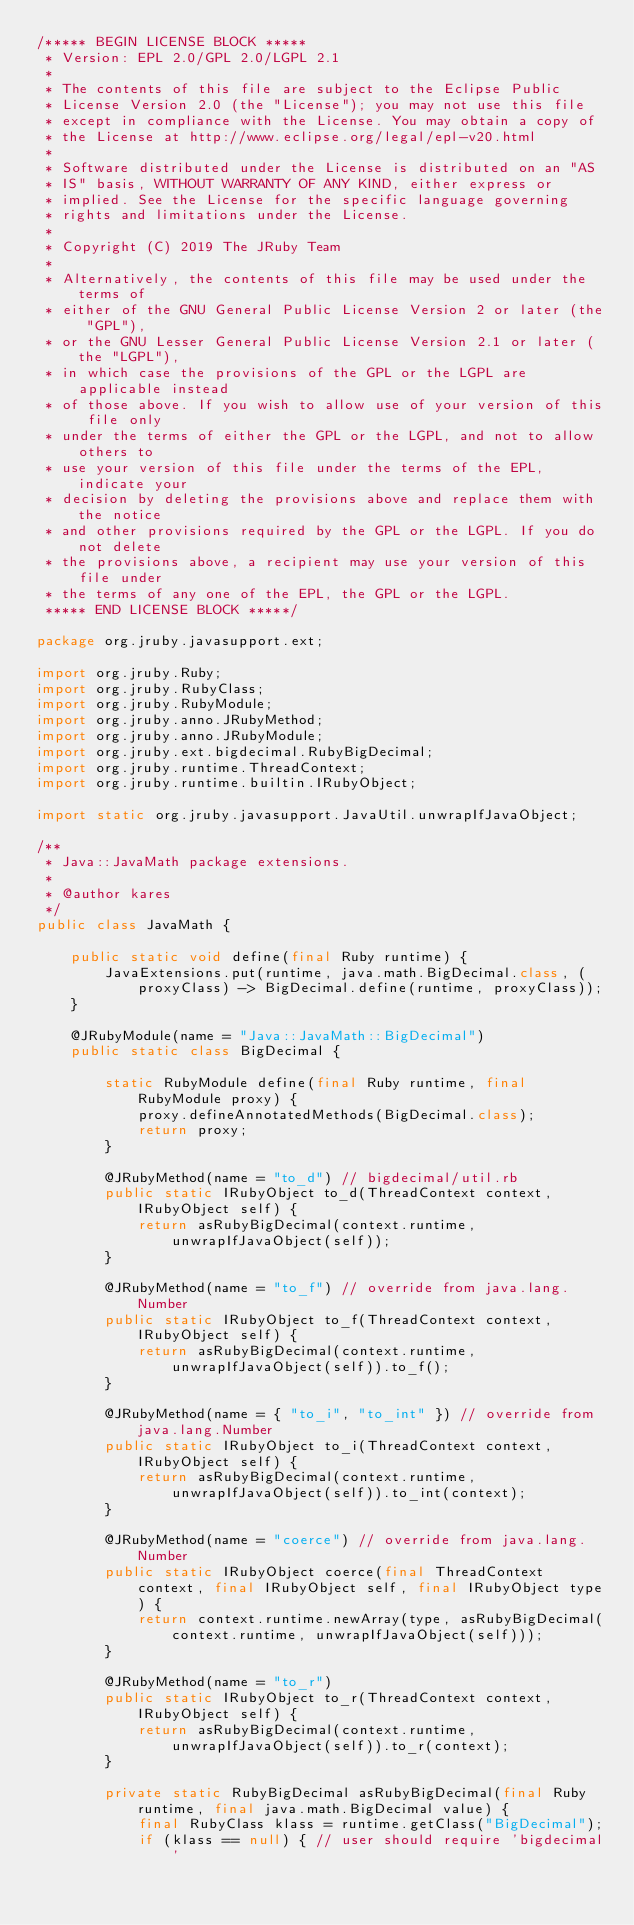Convert code to text. <code><loc_0><loc_0><loc_500><loc_500><_Java_>/***** BEGIN LICENSE BLOCK *****
 * Version: EPL 2.0/GPL 2.0/LGPL 2.1
 *
 * The contents of this file are subject to the Eclipse Public
 * License Version 2.0 (the "License"); you may not use this file
 * except in compliance with the License. You may obtain a copy of
 * the License at http://www.eclipse.org/legal/epl-v20.html
 *
 * Software distributed under the License is distributed on an "AS
 * IS" basis, WITHOUT WARRANTY OF ANY KIND, either express or
 * implied. See the License for the specific language governing
 * rights and limitations under the License.
 *
 * Copyright (C) 2019 The JRuby Team
 *
 * Alternatively, the contents of this file may be used under the terms of
 * either of the GNU General Public License Version 2 or later (the "GPL"),
 * or the GNU Lesser General Public License Version 2.1 or later (the "LGPL"),
 * in which case the provisions of the GPL or the LGPL are applicable instead
 * of those above. If you wish to allow use of your version of this file only
 * under the terms of either the GPL or the LGPL, and not to allow others to
 * use your version of this file under the terms of the EPL, indicate your
 * decision by deleting the provisions above and replace them with the notice
 * and other provisions required by the GPL or the LGPL. If you do not delete
 * the provisions above, a recipient may use your version of this file under
 * the terms of any one of the EPL, the GPL or the LGPL.
 ***** END LICENSE BLOCK *****/

package org.jruby.javasupport.ext;

import org.jruby.Ruby;
import org.jruby.RubyClass;
import org.jruby.RubyModule;
import org.jruby.anno.JRubyMethod;
import org.jruby.anno.JRubyModule;
import org.jruby.ext.bigdecimal.RubyBigDecimal;
import org.jruby.runtime.ThreadContext;
import org.jruby.runtime.builtin.IRubyObject;

import static org.jruby.javasupport.JavaUtil.unwrapIfJavaObject;

/**
 * Java::JavaMath package extensions.
 *
 * @author kares
 */
public class JavaMath {

    public static void define(final Ruby runtime) {
        JavaExtensions.put(runtime, java.math.BigDecimal.class, (proxyClass) -> BigDecimal.define(runtime, proxyClass));
    }

    @JRubyModule(name = "Java::JavaMath::BigDecimal")
    public static class BigDecimal {

        static RubyModule define(final Ruby runtime, final RubyModule proxy) {
            proxy.defineAnnotatedMethods(BigDecimal.class);
            return proxy;
        }

        @JRubyMethod(name = "to_d") // bigdecimal/util.rb
        public static IRubyObject to_d(ThreadContext context, IRubyObject self) {
            return asRubyBigDecimal(context.runtime, unwrapIfJavaObject(self));
        }

        @JRubyMethod(name = "to_f") // override from java.lang.Number
        public static IRubyObject to_f(ThreadContext context, IRubyObject self) {
            return asRubyBigDecimal(context.runtime, unwrapIfJavaObject(self)).to_f();
        }

        @JRubyMethod(name = { "to_i", "to_int" }) // override from java.lang.Number
        public static IRubyObject to_i(ThreadContext context, IRubyObject self) {
            return asRubyBigDecimal(context.runtime, unwrapIfJavaObject(self)).to_int(context);
        }

        @JRubyMethod(name = "coerce") // override from java.lang.Number
        public static IRubyObject coerce(final ThreadContext context, final IRubyObject self, final IRubyObject type) {
            return context.runtime.newArray(type, asRubyBigDecimal(context.runtime, unwrapIfJavaObject(self)));
        }

        @JRubyMethod(name = "to_r")
        public static IRubyObject to_r(ThreadContext context, IRubyObject self) {
            return asRubyBigDecimal(context.runtime, unwrapIfJavaObject(self)).to_r(context);
        }

        private static RubyBigDecimal asRubyBigDecimal(final Ruby runtime, final java.math.BigDecimal value) {
            final RubyClass klass = runtime.getClass("BigDecimal");
            if (klass == null) { // user should require 'bigdecimal'</code> 